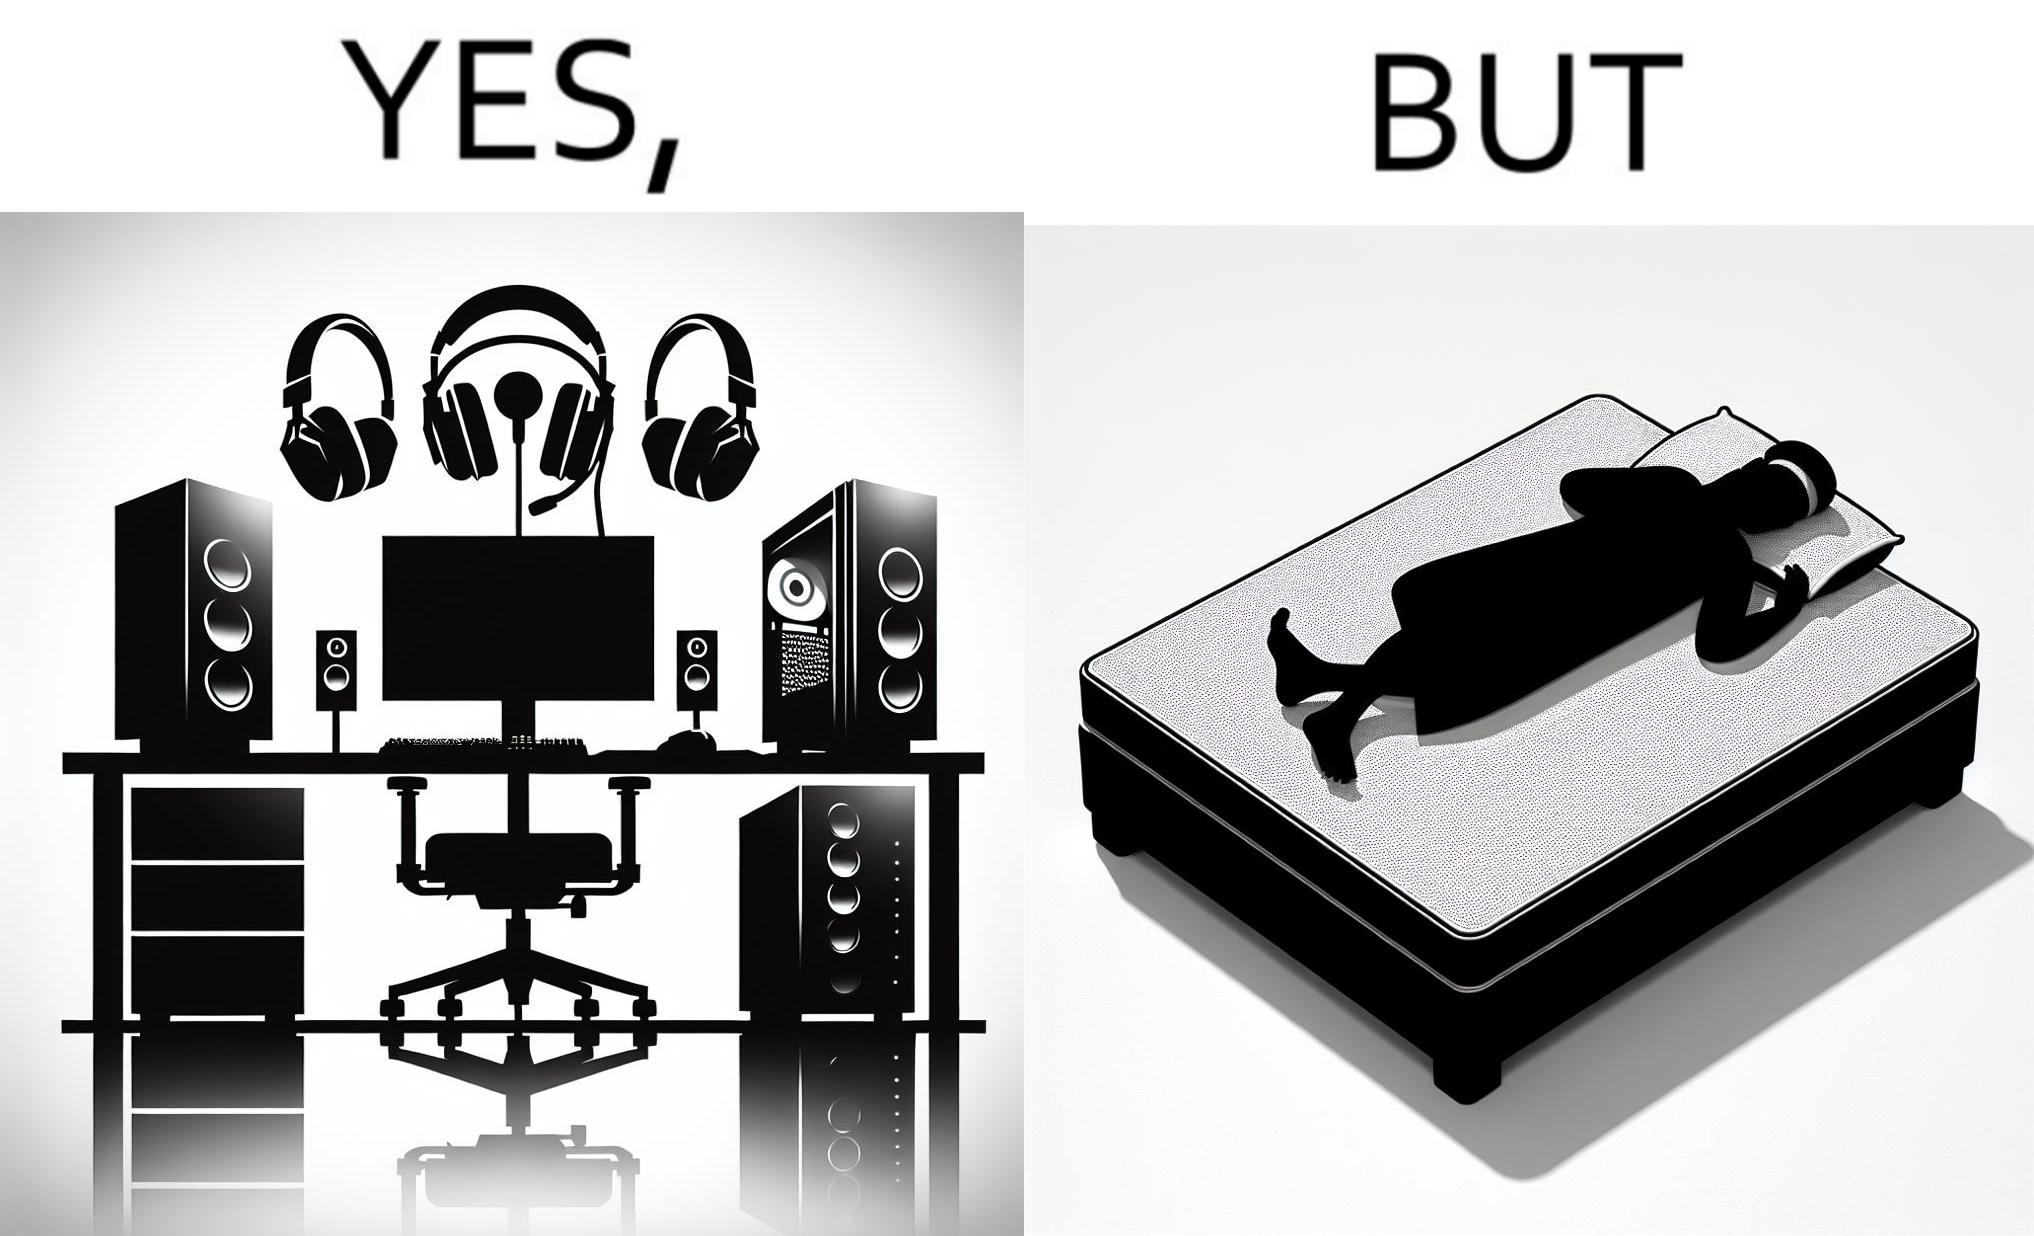Is this image satirical or non-satirical? Yes, this image is satirical. 